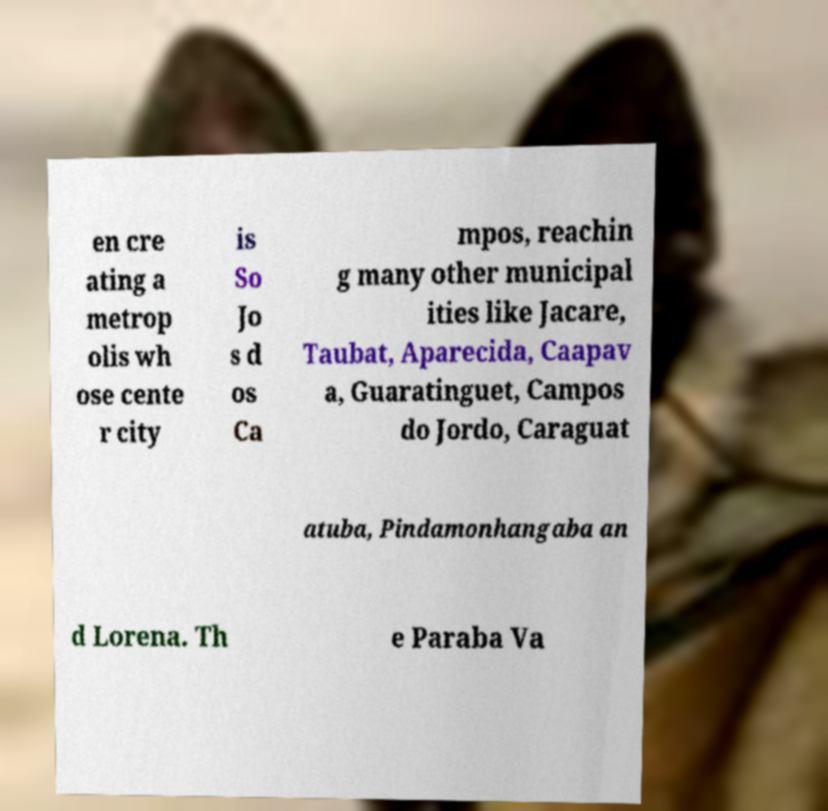Could you assist in decoding the text presented in this image and type it out clearly? en cre ating a metrop olis wh ose cente r city is So Jo s d os Ca mpos, reachin g many other municipal ities like Jacare, Taubat, Aparecida, Caapav a, Guaratinguet, Campos do Jordo, Caraguat atuba, Pindamonhangaba an d Lorena. Th e Paraba Va 